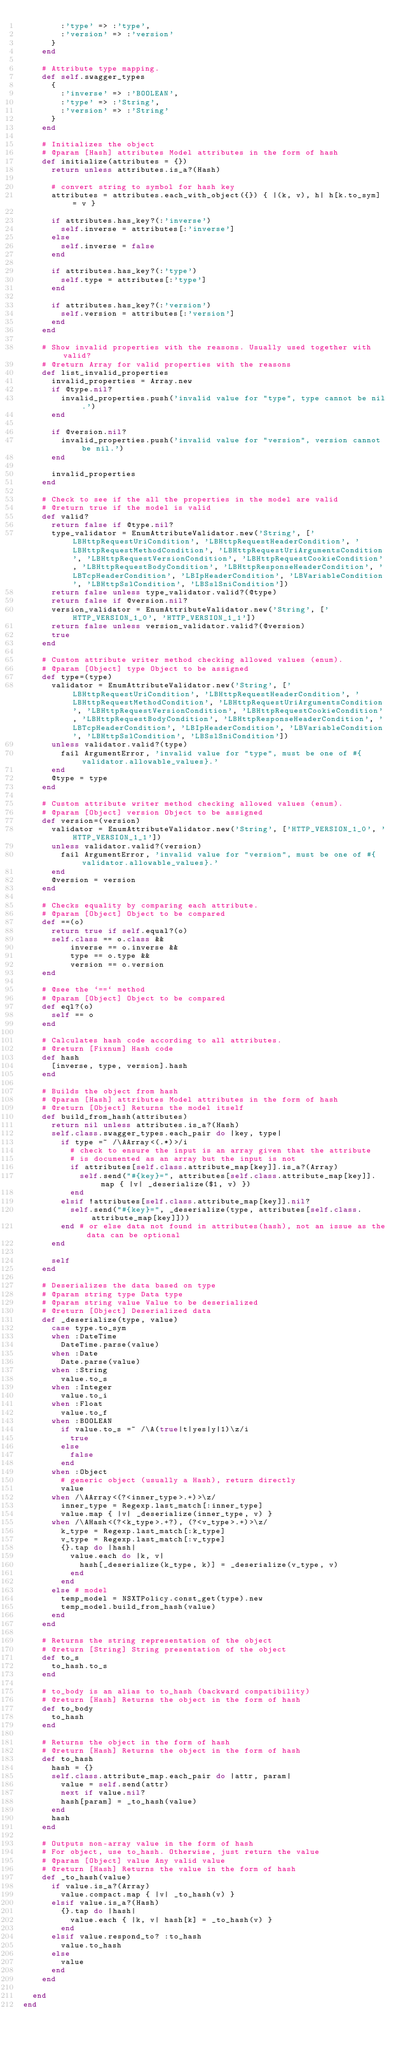Convert code to text. <code><loc_0><loc_0><loc_500><loc_500><_Ruby_>        :'type' => :'type',
        :'version' => :'version'
      }
    end

    # Attribute type mapping.
    def self.swagger_types
      {
        :'inverse' => :'BOOLEAN',
        :'type' => :'String',
        :'version' => :'String'
      }
    end

    # Initializes the object
    # @param [Hash] attributes Model attributes in the form of hash
    def initialize(attributes = {})
      return unless attributes.is_a?(Hash)

      # convert string to symbol for hash key
      attributes = attributes.each_with_object({}) { |(k, v), h| h[k.to_sym] = v }

      if attributes.has_key?(:'inverse')
        self.inverse = attributes[:'inverse']
      else
        self.inverse = false
      end

      if attributes.has_key?(:'type')
        self.type = attributes[:'type']
      end

      if attributes.has_key?(:'version')
        self.version = attributes[:'version']
      end
    end

    # Show invalid properties with the reasons. Usually used together with valid?
    # @return Array for valid properties with the reasons
    def list_invalid_properties
      invalid_properties = Array.new
      if @type.nil?
        invalid_properties.push('invalid value for "type", type cannot be nil.')
      end

      if @version.nil?
        invalid_properties.push('invalid value for "version", version cannot be nil.')
      end

      invalid_properties
    end

    # Check to see if the all the properties in the model are valid
    # @return true if the model is valid
    def valid?
      return false if @type.nil?
      type_validator = EnumAttributeValidator.new('String', ['LBHttpRequestUriCondition', 'LBHttpRequestHeaderCondition', 'LBHttpRequestMethodCondition', 'LBHttpRequestUriArgumentsCondition', 'LBHttpRequestVersionCondition', 'LBHttpRequestCookieCondition', 'LBHttpRequestBodyCondition', 'LBHttpResponseHeaderCondition', 'LBTcpHeaderCondition', 'LBIpHeaderCondition', 'LBVariableCondition', 'LBHttpSslCondition', 'LBSslSniCondition'])
      return false unless type_validator.valid?(@type)
      return false if @version.nil?
      version_validator = EnumAttributeValidator.new('String', ['HTTP_VERSION_1_0', 'HTTP_VERSION_1_1'])
      return false unless version_validator.valid?(@version)
      true
    end

    # Custom attribute writer method checking allowed values (enum).
    # @param [Object] type Object to be assigned
    def type=(type)
      validator = EnumAttributeValidator.new('String', ['LBHttpRequestUriCondition', 'LBHttpRequestHeaderCondition', 'LBHttpRequestMethodCondition', 'LBHttpRequestUriArgumentsCondition', 'LBHttpRequestVersionCondition', 'LBHttpRequestCookieCondition', 'LBHttpRequestBodyCondition', 'LBHttpResponseHeaderCondition', 'LBTcpHeaderCondition', 'LBIpHeaderCondition', 'LBVariableCondition', 'LBHttpSslCondition', 'LBSslSniCondition'])
      unless validator.valid?(type)
        fail ArgumentError, 'invalid value for "type", must be one of #{validator.allowable_values}.'
      end
      @type = type
    end

    # Custom attribute writer method checking allowed values (enum).
    # @param [Object] version Object to be assigned
    def version=(version)
      validator = EnumAttributeValidator.new('String', ['HTTP_VERSION_1_0', 'HTTP_VERSION_1_1'])
      unless validator.valid?(version)
        fail ArgumentError, 'invalid value for "version", must be one of #{validator.allowable_values}.'
      end
      @version = version
    end

    # Checks equality by comparing each attribute.
    # @param [Object] Object to be compared
    def ==(o)
      return true if self.equal?(o)
      self.class == o.class &&
          inverse == o.inverse &&
          type == o.type &&
          version == o.version
    end

    # @see the `==` method
    # @param [Object] Object to be compared
    def eql?(o)
      self == o
    end

    # Calculates hash code according to all attributes.
    # @return [Fixnum] Hash code
    def hash
      [inverse, type, version].hash
    end

    # Builds the object from hash
    # @param [Hash] attributes Model attributes in the form of hash
    # @return [Object] Returns the model itself
    def build_from_hash(attributes)
      return nil unless attributes.is_a?(Hash)
      self.class.swagger_types.each_pair do |key, type|
        if type =~ /\AArray<(.*)>/i
          # check to ensure the input is an array given that the attribute
          # is documented as an array but the input is not
          if attributes[self.class.attribute_map[key]].is_a?(Array)
            self.send("#{key}=", attributes[self.class.attribute_map[key]].map { |v| _deserialize($1, v) })
          end
        elsif !attributes[self.class.attribute_map[key]].nil?
          self.send("#{key}=", _deserialize(type, attributes[self.class.attribute_map[key]]))
        end # or else data not found in attributes(hash), not an issue as the data can be optional
      end

      self
    end

    # Deserializes the data based on type
    # @param string type Data type
    # @param string value Value to be deserialized
    # @return [Object] Deserialized data
    def _deserialize(type, value)
      case type.to_sym
      when :DateTime
        DateTime.parse(value)
      when :Date
        Date.parse(value)
      when :String
        value.to_s
      when :Integer
        value.to_i
      when :Float
        value.to_f
      when :BOOLEAN
        if value.to_s =~ /\A(true|t|yes|y|1)\z/i
          true
        else
          false
        end
      when :Object
        # generic object (usually a Hash), return directly
        value
      when /\AArray<(?<inner_type>.+)>\z/
        inner_type = Regexp.last_match[:inner_type]
        value.map { |v| _deserialize(inner_type, v) }
      when /\AHash<(?<k_type>.+?), (?<v_type>.+)>\z/
        k_type = Regexp.last_match[:k_type]
        v_type = Regexp.last_match[:v_type]
        {}.tap do |hash|
          value.each do |k, v|
            hash[_deserialize(k_type, k)] = _deserialize(v_type, v)
          end
        end
      else # model
        temp_model = NSXTPolicy.const_get(type).new
        temp_model.build_from_hash(value)
      end
    end

    # Returns the string representation of the object
    # @return [String] String presentation of the object
    def to_s
      to_hash.to_s
    end

    # to_body is an alias to to_hash (backward compatibility)
    # @return [Hash] Returns the object in the form of hash
    def to_body
      to_hash
    end

    # Returns the object in the form of hash
    # @return [Hash] Returns the object in the form of hash
    def to_hash
      hash = {}
      self.class.attribute_map.each_pair do |attr, param|
        value = self.send(attr)
        next if value.nil?
        hash[param] = _to_hash(value)
      end
      hash
    end

    # Outputs non-array value in the form of hash
    # For object, use to_hash. Otherwise, just return the value
    # @param [Object] value Any valid value
    # @return [Hash] Returns the value in the form of hash
    def _to_hash(value)
      if value.is_a?(Array)
        value.compact.map { |v| _to_hash(v) }
      elsif value.is_a?(Hash)
        {}.tap do |hash|
          value.each { |k, v| hash[k] = _to_hash(v) }
        end
      elsif value.respond_to? :to_hash
        value.to_hash
      else
        value
      end
    end

  end
end
</code> 